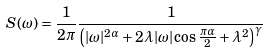Convert formula to latex. <formula><loc_0><loc_0><loc_500><loc_500>S ( \omega ) = \frac { 1 } { 2 \pi } \frac { 1 } { \left ( | \omega | ^ { 2 \alpha } + 2 \lambda | \omega | \cos \frac { \pi \alpha } { 2 } + \lambda ^ { 2 } \right ) ^ { \gamma } }</formula> 